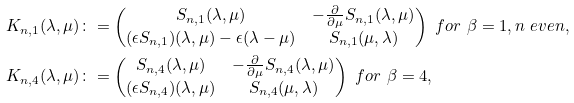Convert formula to latex. <formula><loc_0><loc_0><loc_500><loc_500>K _ { n , 1 } ( \lambda , \mu ) & \colon = \begin{pmatrix} S _ { n , 1 } ( \lambda , \mu ) & - \frac { \partial } { \partial \mu } S _ { n , 1 } ( \lambda , \mu ) \\ ( \epsilon S _ { n , 1 } ) ( \lambda , \mu ) - \epsilon ( \lambda - \mu ) & S _ { n , 1 } ( \mu , \lambda ) \end{pmatrix} \ f o r \ \beta = 1 , n \ e v e n , \\ K _ { n , 4 } ( \lambda , \mu ) & \colon = \begin{pmatrix} S _ { n , 4 } ( \lambda , \mu ) & - \frac { \partial } { \partial \mu } S _ { n , 4 } ( \lambda , \mu ) \\ ( \epsilon S _ { n , 4 } ) ( \lambda , \mu ) & S _ { n , 4 } ( \mu , \lambda ) \end{pmatrix} \ f o r \ \beta = 4 ,</formula> 